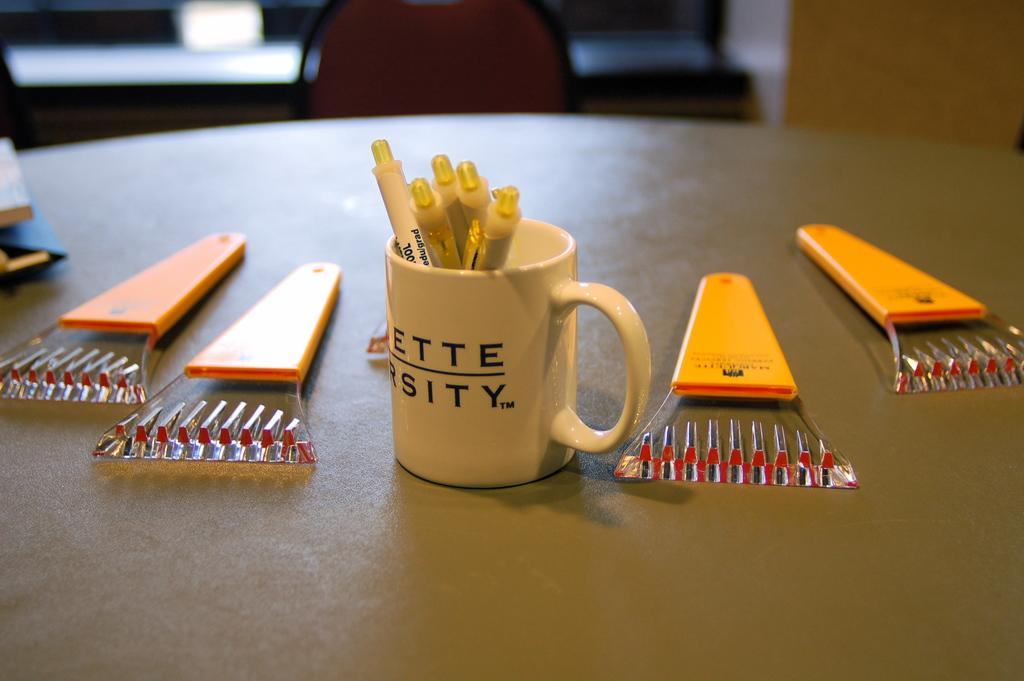What is located in the foreground of the image? There is a table in the foreground of the image. What is on the table? There is a cup with testers and electrical connectors on the table. Can you describe the background of the image? There is a chair in the background of the image. What type of heart can be seen beating in the image? There is no heart visible in the image; it features a table with a cup, testers, and electrical connectors, as well as a chair in the background. 